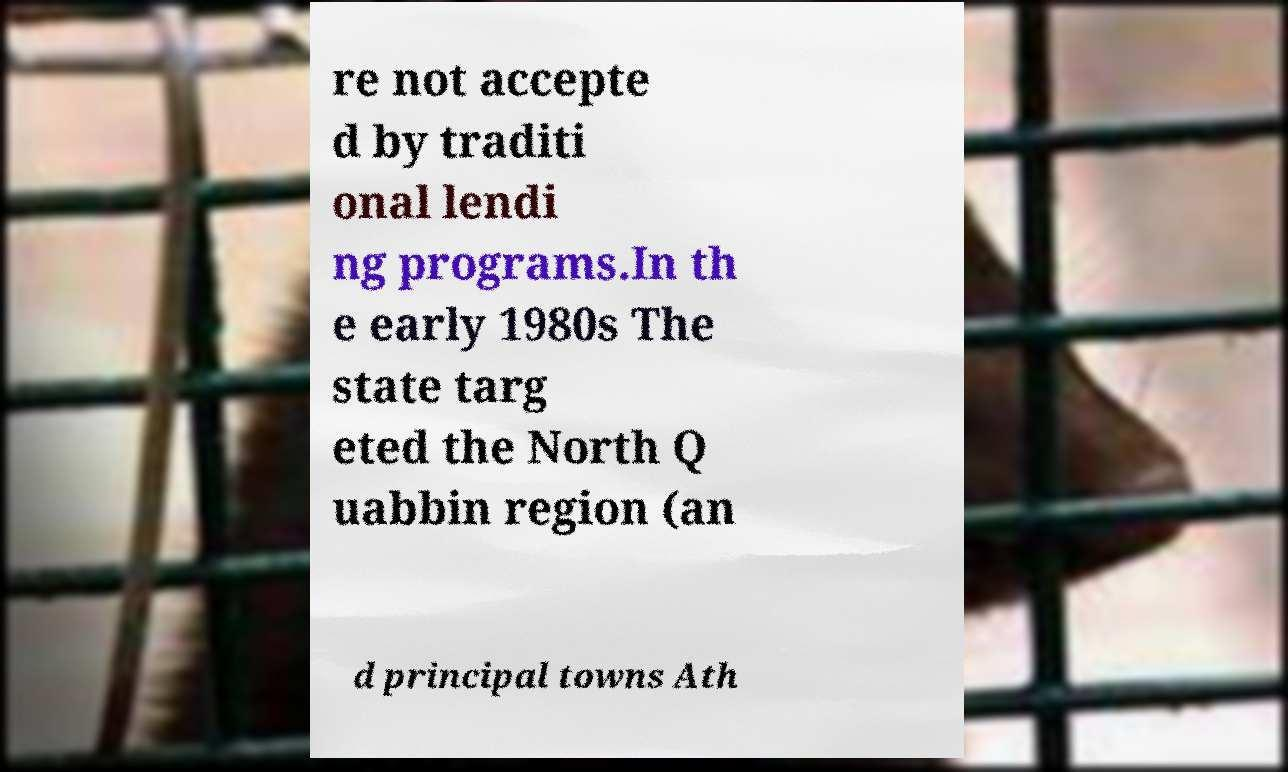Please identify and transcribe the text found in this image. re not accepte d by traditi onal lendi ng programs.In th e early 1980s The state targ eted the North Q uabbin region (an d principal towns Ath 